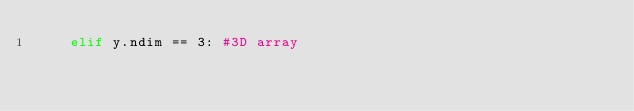Convert code to text. <code><loc_0><loc_0><loc_500><loc_500><_Python_>    elif y.ndim == 3: #3D array</code> 